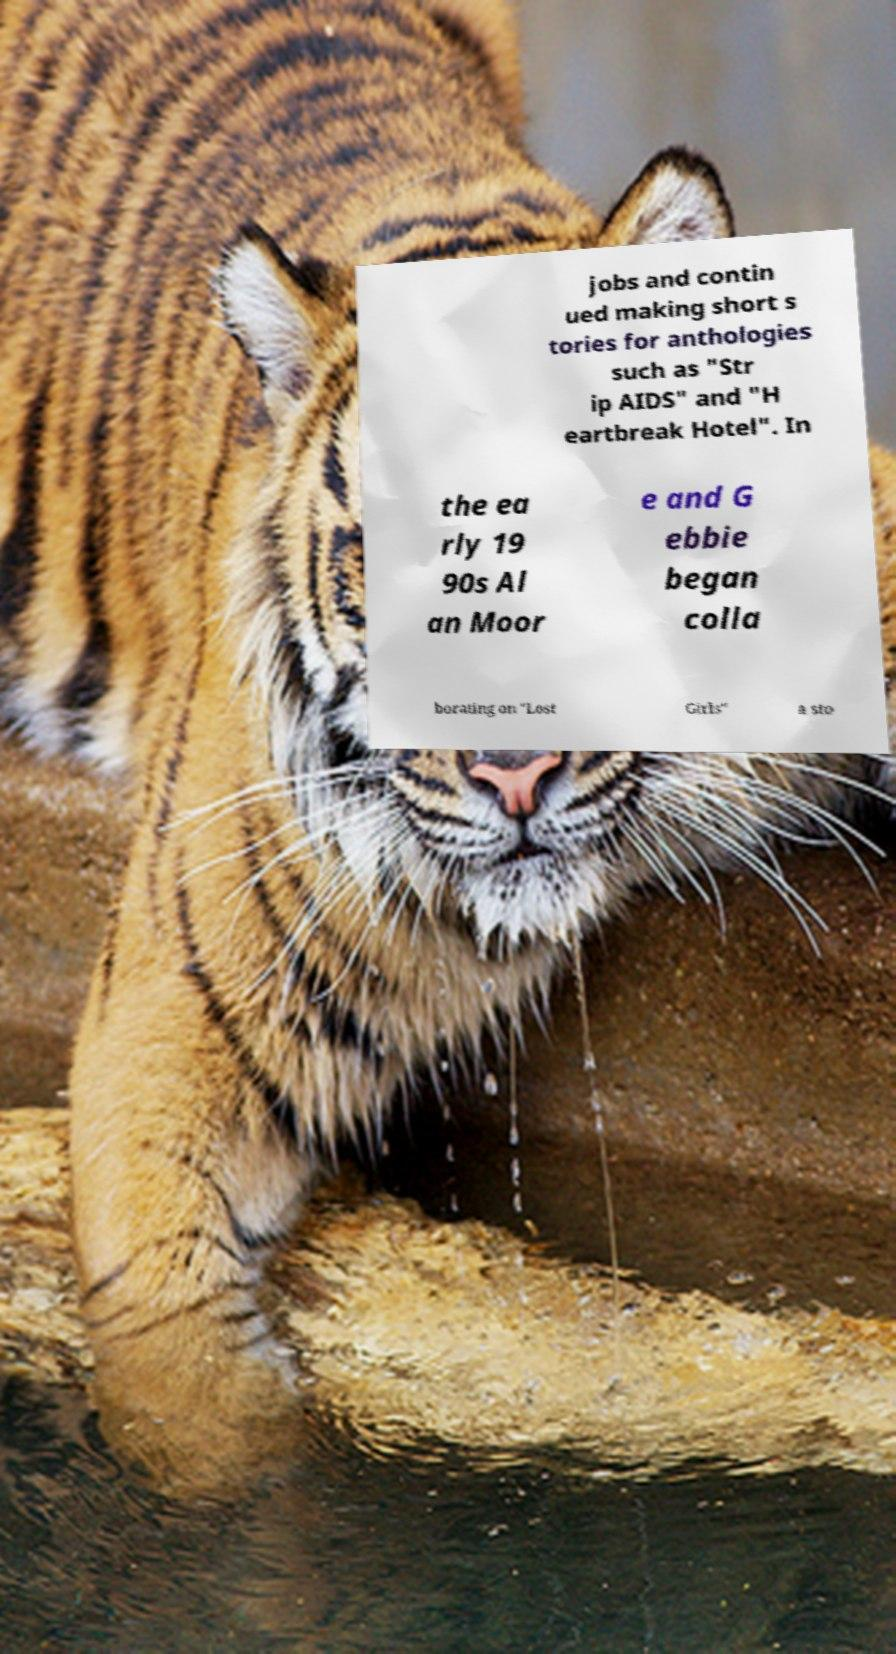For documentation purposes, I need the text within this image transcribed. Could you provide that? jobs and contin ued making short s tories for anthologies such as "Str ip AIDS" and "H eartbreak Hotel". In the ea rly 19 90s Al an Moor e and G ebbie began colla borating on "Lost Girls" a sto 